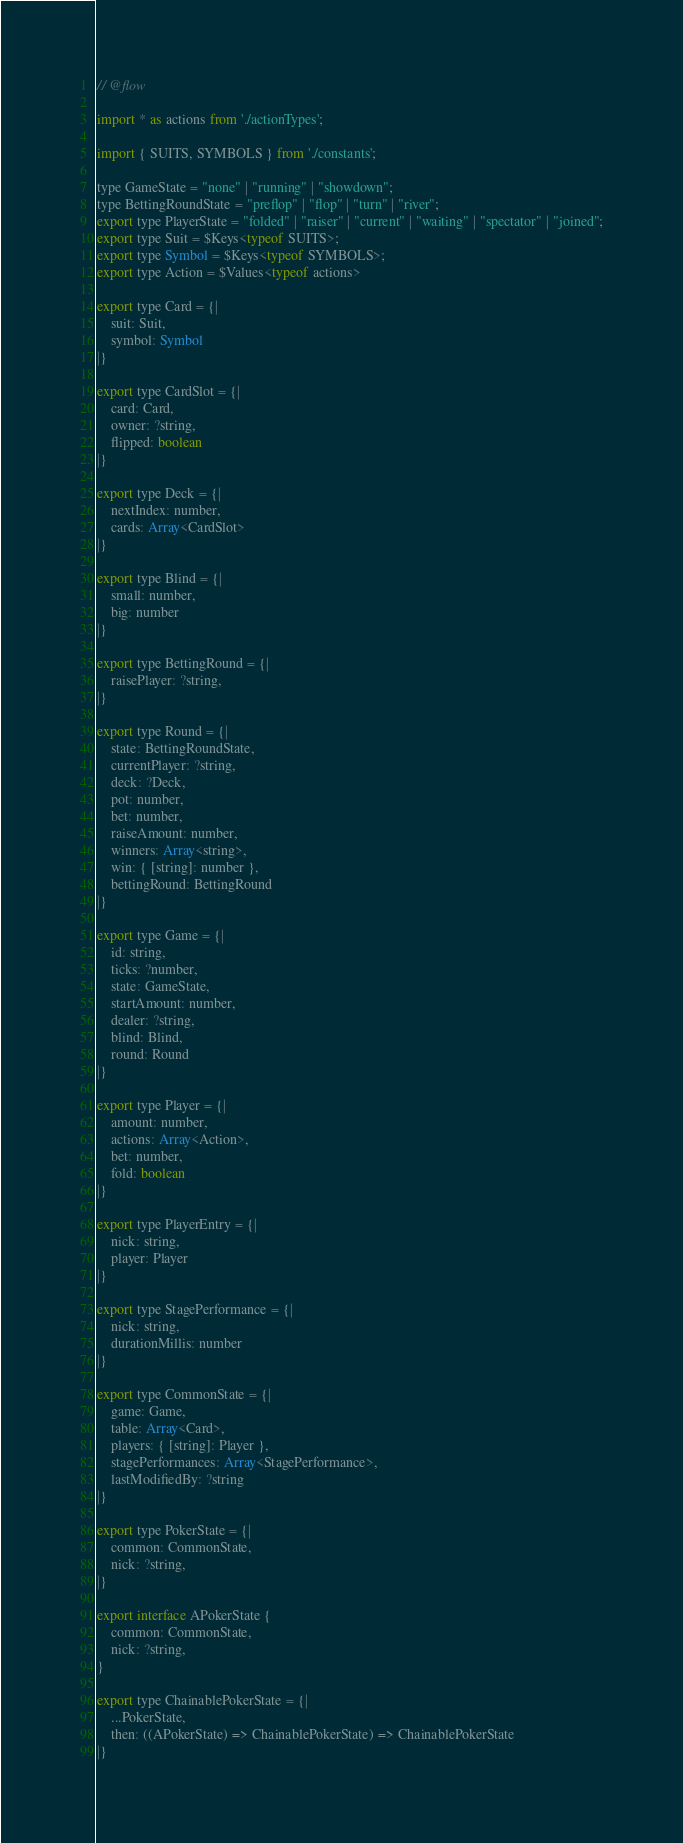<code> <loc_0><loc_0><loc_500><loc_500><_JavaScript_>// @flow

import * as actions from './actionTypes';

import { SUITS, SYMBOLS } from './constants';

type GameState = "none" | "running" | "showdown";
type BettingRoundState = "preflop" | "flop" | "turn" | "river";
export type PlayerState = "folded" | "raiser" | "current" | "waiting" | "spectator" | "joined";
export type Suit = $Keys<typeof SUITS>;
export type Symbol = $Keys<typeof SYMBOLS>;
export type Action = $Values<typeof actions>

export type Card = {|
    suit: Suit,
    symbol: Symbol
|}

export type CardSlot = {|
    card: Card,
    owner: ?string,
    flipped: boolean
|}

export type Deck = {|
    nextIndex: number,
    cards: Array<CardSlot>
|}

export type Blind = {|
    small: number,
    big: number
|}

export type BettingRound = {|
    raisePlayer: ?string,
|}

export type Round = {|
    state: BettingRoundState,
    currentPlayer: ?string,
    deck: ?Deck,
    pot: number,
    bet: number,
    raiseAmount: number,
    winners: Array<string>,
    win: { [string]: number },
    bettingRound: BettingRound
|}

export type Game = {|
    id: string,
    ticks: ?number,
    state: GameState,
    startAmount: number,
    dealer: ?string,
    blind: Blind,
    round: Round
|}

export type Player = {|
    amount: number,
    actions: Array<Action>,
    bet: number,
    fold: boolean
|}

export type PlayerEntry = {|
    nick: string,
    player: Player
|}

export type StagePerformance = {|
    nick: string,
    durationMillis: number
|}

export type CommonState = {|
    game: Game,
    table: Array<Card>,
    players: { [string]: Player },
    stagePerformances: Array<StagePerformance>,
    lastModifiedBy: ?string
|}

export type PokerState = {|
    common: CommonState,
    nick: ?string,
|}

export interface APokerState {
    common: CommonState,
    nick: ?string,
}

export type ChainablePokerState = {|
    ...PokerState,
    then: ((APokerState) => ChainablePokerState) => ChainablePokerState
|}
</code> 